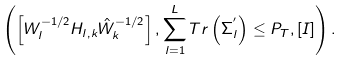Convert formula to latex. <formula><loc_0><loc_0><loc_500><loc_500>\left ( \left [ W _ { l } ^ { - 1 / 2 } H _ { l , k } \hat { W } _ { k } ^ { - 1 / 2 } \right ] , \sum _ { l = 1 } ^ { L } T r \left ( \Sigma _ { l } ^ { ^ { \prime } } \right ) \leq P _ { T } , \left [ I \right ] \right ) .</formula> 